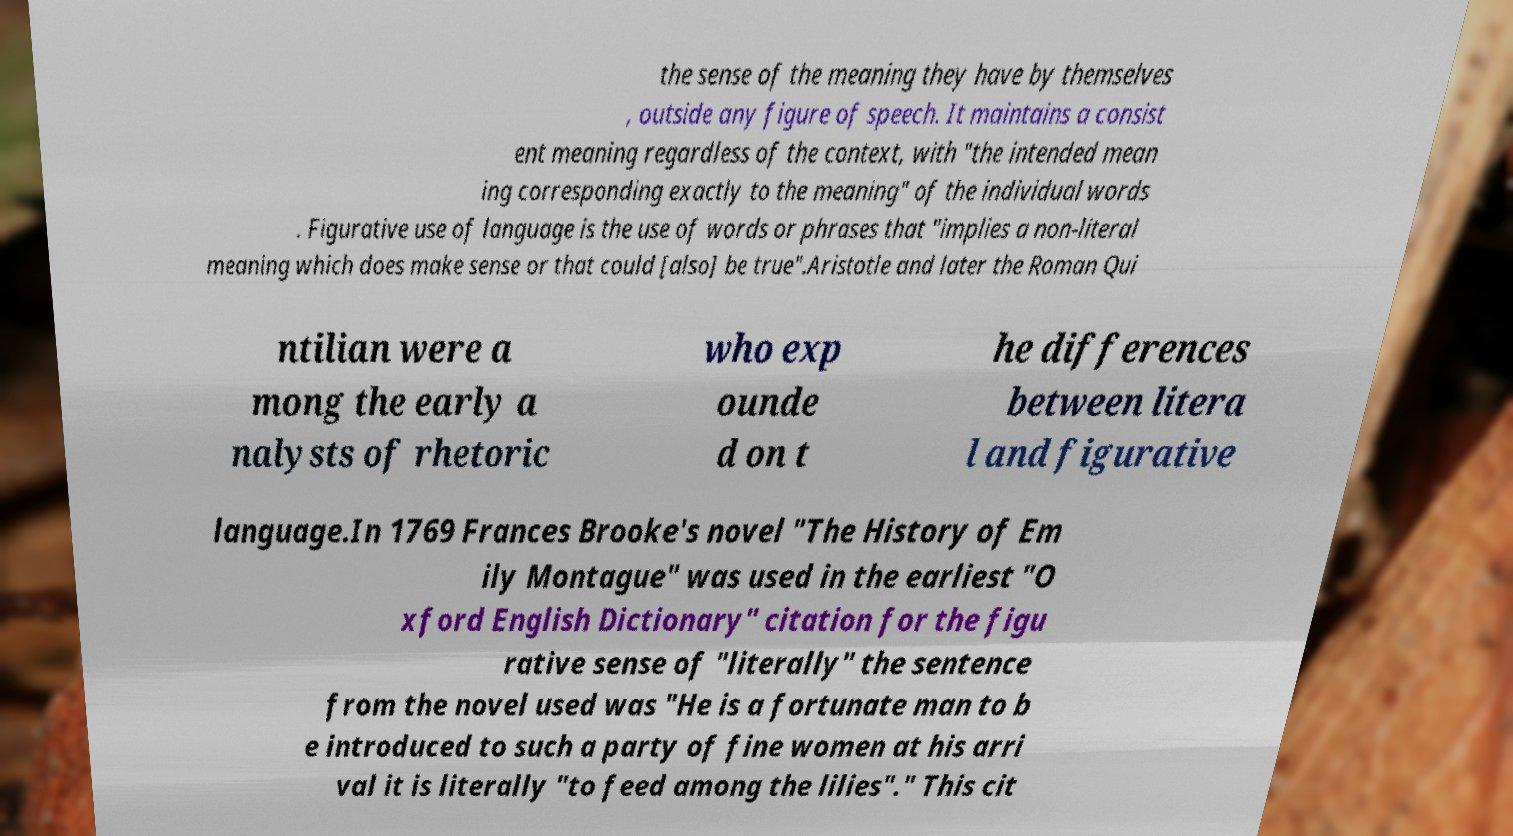Can you read and provide the text displayed in the image?This photo seems to have some interesting text. Can you extract and type it out for me? the sense of the meaning they have by themselves , outside any figure of speech. It maintains a consist ent meaning regardless of the context, with "the intended mean ing corresponding exactly to the meaning" of the individual words . Figurative use of language is the use of words or phrases that "implies a non-literal meaning which does make sense or that could [also] be true".Aristotle and later the Roman Qui ntilian were a mong the early a nalysts of rhetoric who exp ounde d on t he differences between litera l and figurative language.In 1769 Frances Brooke's novel "The History of Em ily Montague" was used in the earliest "O xford English Dictionary" citation for the figu rative sense of "literally" the sentence from the novel used was "He is a fortunate man to b e introduced to such a party of fine women at his arri val it is literally "to feed among the lilies"." This cit 